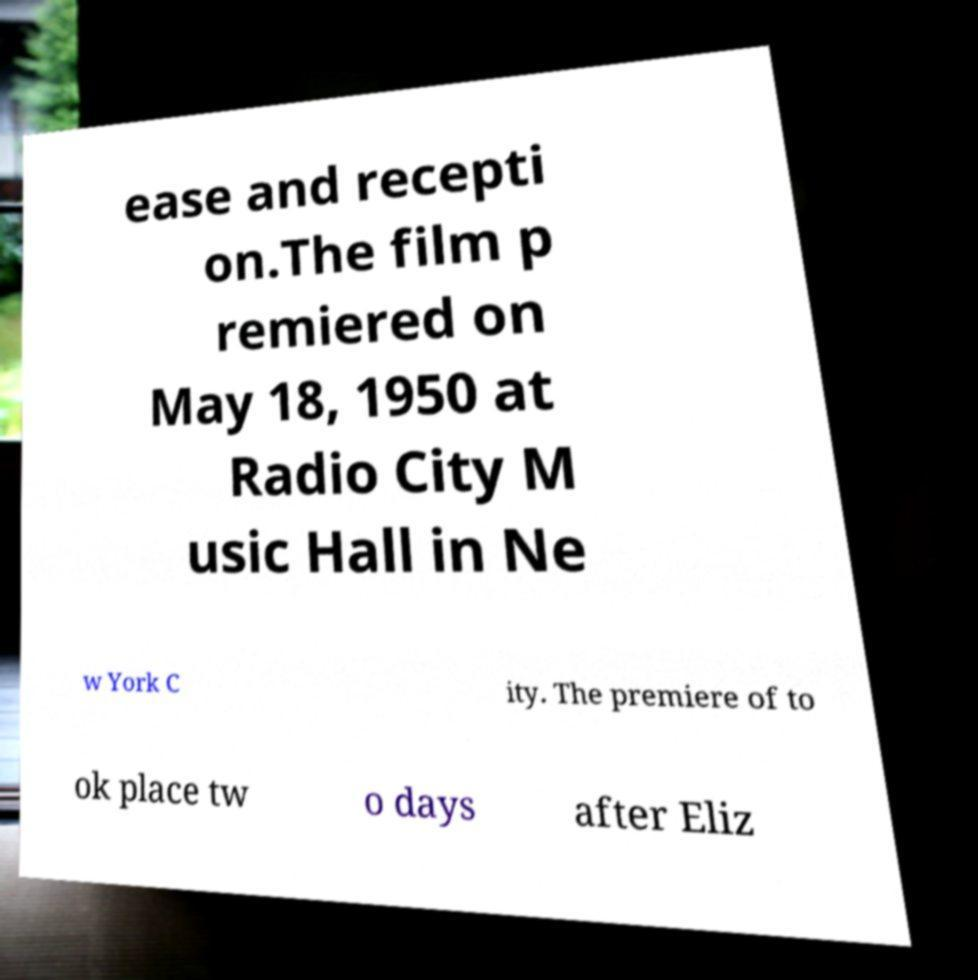What messages or text are displayed in this image? I need them in a readable, typed format. ease and recepti on.The film p remiered on May 18, 1950 at Radio City M usic Hall in Ne w York C ity. The premiere of to ok place tw o days after Eliz 